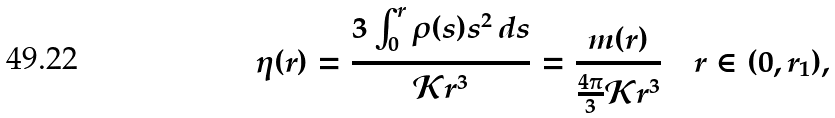Convert formula to latex. <formula><loc_0><loc_0><loc_500><loc_500>\eta ( r ) = \frac { 3 \int _ { 0 } ^ { r } \rho ( s ) s ^ { 2 } \, d s } { \mathcal { K } r ^ { 3 } } = \frac { m ( r ) } { \frac { 4 \pi } { 3 } \mathcal { K } r ^ { 3 } } \quad r \in ( 0 , r _ { 1 } ) ,</formula> 